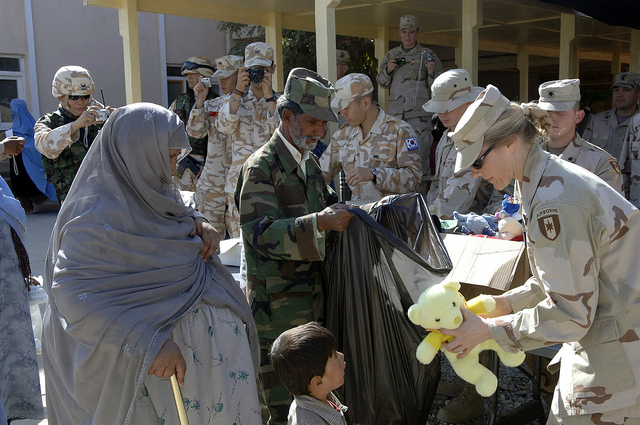Can you tell me more about the people involved in this scene? Certainly! The scene is filled with a mixture of military personnel and local civilians. The soldiers, dressed in various camouflage uniforms, are engaged in distributing aid. One soldier is handing out a teddy bear to a child while another soldier assists in holding a large bag. The local civilians, including women wearing headscarves and children, are receiving the items being distributed. The soldiers appear to be from different divisions, indicated by varying uniform patterns. The overall mood suggests a cooperative and supportive interaction between the military and the civilian population. What's the significance of the teddy bear being handed out? The teddy bear being handed out symbolizes a gesture of kindness and an effort to bring comfort and normalcy to children in a challenging environment. Toys like teddy bears are often distributed during humanitarian missions to provide emotional relief and a sense of security to young children who might be affected by conflict or disaster. This simple act can have significant psychological benefits, offering a semblance of childhood innocence and joy amidst difficult circumstances. How might this event impact the local community in the long run? This event could have several long-term impacts on the local community. Firstly, it may foster a sense of goodwill and trust between the community and the military personnel, potentially improving relations and cooperation in future interactions. The distribution of essential items and toys can also provide immediate relief, support, and comfort to the recipients, alleviating some of their hardships. Moreover, such events can lay the foundation for ongoing humanitarian efforts and community support initiatives, contributing to the community’s resilience and recovery. 